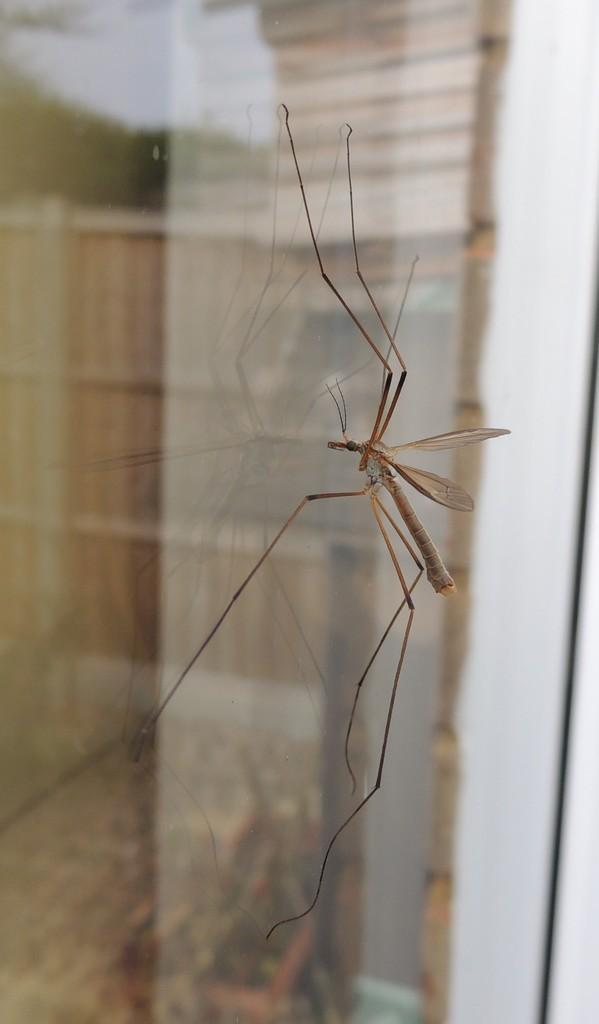Could you give a brief overview of what you see in this image? In this image we can see an insect on the glass. The background is blurry. 